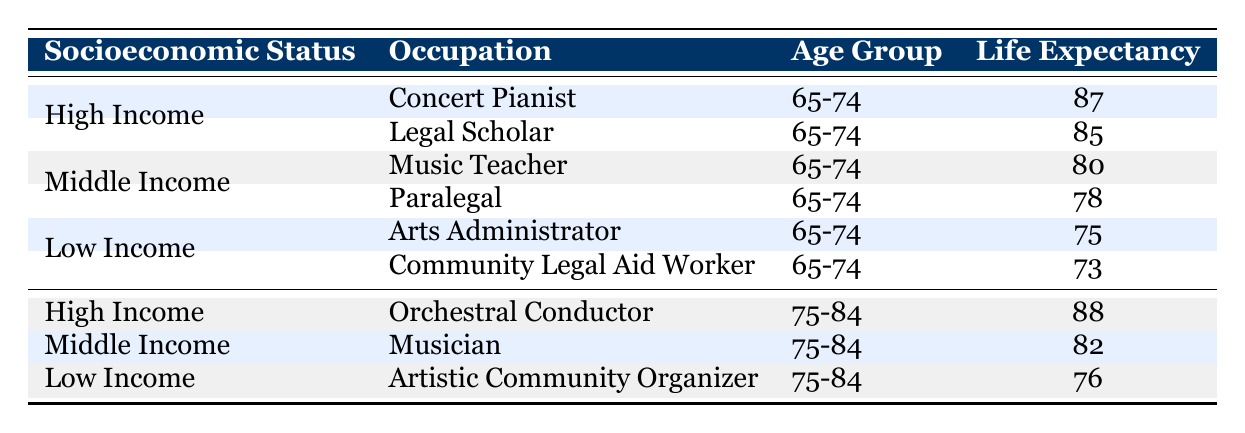What is the life expectancy of a concert pianist in the age group 65-74? According to the table, the life expectancy for a concert pianist in the age group 65-74 is listed as 87 years.
Answer: 87 What is the lowest life expectancy recorded for individuals in the age group 65-74? Looking through the table, the lowest life expectancy for the age group 65-74 is for the Community Legal Aid Worker, which is 73 years.
Answer: 73 Is the life expectancy of a musician higher than that of an arts administrator? The life expectancy of a musician in the age group 75-84 is 82 years, while the arts administrator in the age group 65-74 has a life expectancy of 75 years. Since 82 is greater than 75, the answer is yes.
Answer: Yes What is the life expectancy difference between the highest and lowest recorded in the age group 75-84? The highest life expectancy in the age group 75-84 is for the Orchestral Conductor at 88 years, and the lowest is for the Artistic Community Organizer at 76 years. The difference is calculated as 88 - 76 = 12 years.
Answer: 12 What is the average life expectancy for individuals in the age group 65-74? To find the average, we sum the life expectancies: 87 (Concert Pianist) + 85 (Legal Scholar) + 80 (Music Teacher) + 78 (Paralegal) + 75 (Arts Administrator) + 73 (Community Legal Aid Worker) = 478. Then, we divide by the number of occupations, which is 6. The average is 478/6 = 79.67, rounding down gives 79.
Answer: 79 Is the life expectancy of a legal scholar lower than that of a music teacher? The life expectancy for a legal scholar is 85 years, and for a music teacher, it is 80 years. Since 85 is greater than 80, the answer is no.
Answer: No What socioeconomic status has the highest life expectancy for the age group 75-84? Among the age group 75-84, the highest life expectancy is for the Orchestral Conductor, who falls under the High Income category, at 88 years. Therefore, the socioeconomic status with the highest life expectancy is High Income.
Answer: High Income Does a middle-income musician have a higher life expectancy than a low-income community legal aid worker? The musician has a life expectancy of 82 years, while the community legal aid worker has a life expectancy of 73 years. Since 82 is greater than 73, the answer is yes.
Answer: Yes 